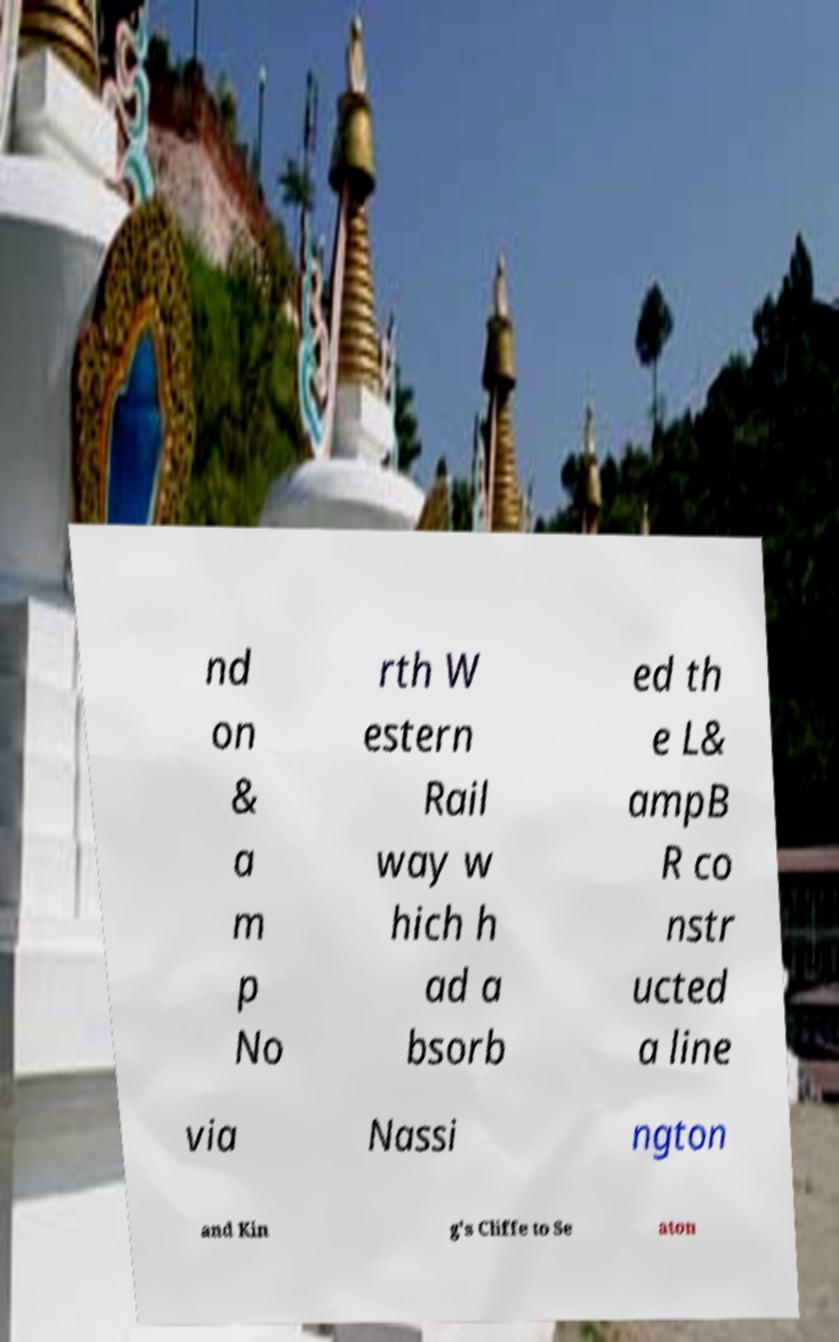There's text embedded in this image that I need extracted. Can you transcribe it verbatim? nd on & a m p No rth W estern Rail way w hich h ad a bsorb ed th e L& ampB R co nstr ucted a line via Nassi ngton and Kin g's Cliffe to Se aton 